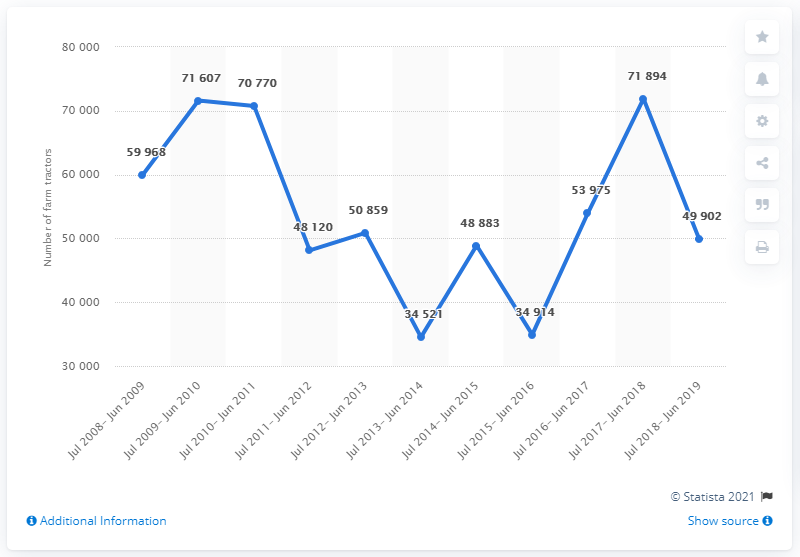Indicate a few pertinent items in this graphic. During the period of July 2018 and June 2019, a total of 49,902 farm tractors were produced in Pakistan. 